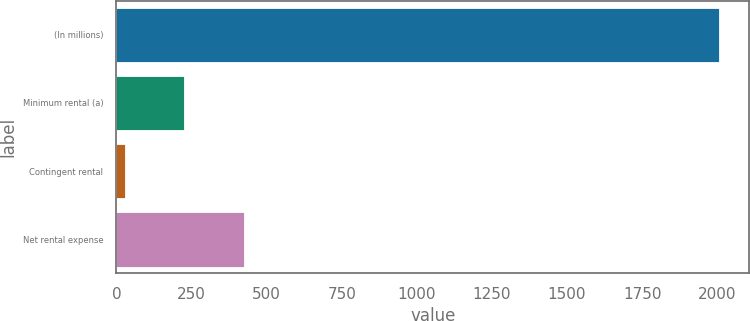Convert chart. <chart><loc_0><loc_0><loc_500><loc_500><bar_chart><fcel>(In millions)<fcel>Minimum rental (a)<fcel>Contingent rental<fcel>Net rental expense<nl><fcel>2006<fcel>225.8<fcel>28<fcel>423.6<nl></chart> 